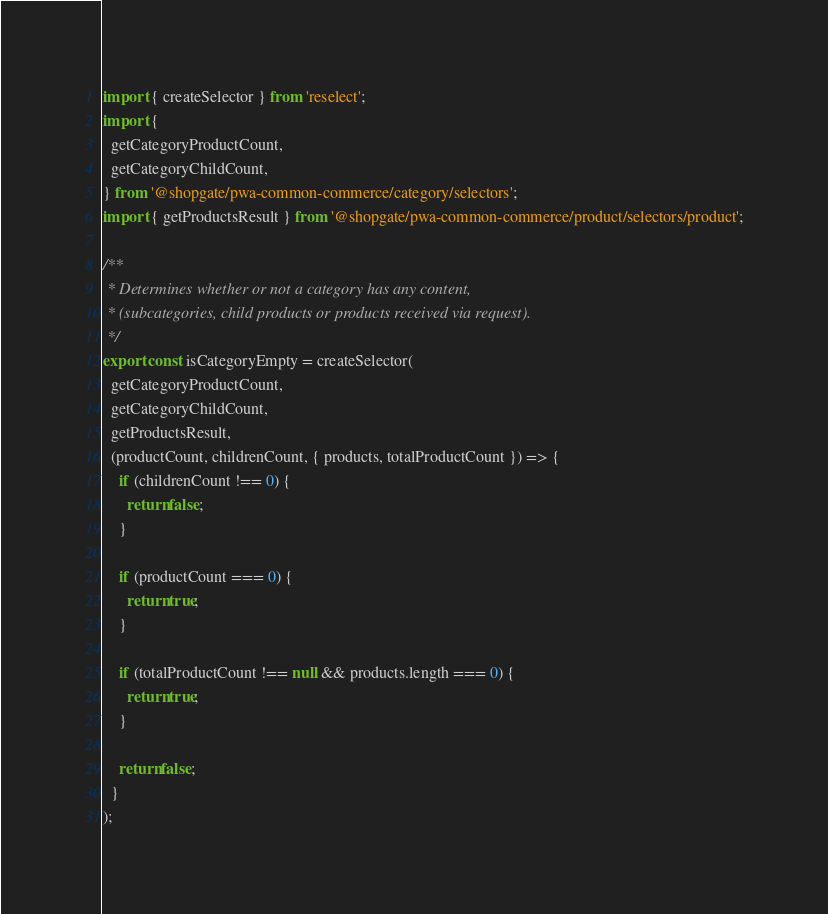<code> <loc_0><loc_0><loc_500><loc_500><_JavaScript_>import { createSelector } from 'reselect';
import {
  getCategoryProductCount,
  getCategoryChildCount,
} from '@shopgate/pwa-common-commerce/category/selectors';
import { getProductsResult } from '@shopgate/pwa-common-commerce/product/selectors/product';

/**
 * Determines whether or not a category has any content,
 * (subcategories, child products or products received via request).
 */
export const isCategoryEmpty = createSelector(
  getCategoryProductCount,
  getCategoryChildCount,
  getProductsResult,
  (productCount, childrenCount, { products, totalProductCount }) => {
    if (childrenCount !== 0) {
      return false;
    }

    if (productCount === 0) {
      return true;
    }

    if (totalProductCount !== null && products.length === 0) {
      return true;
    }

    return false;
  }
);
</code> 